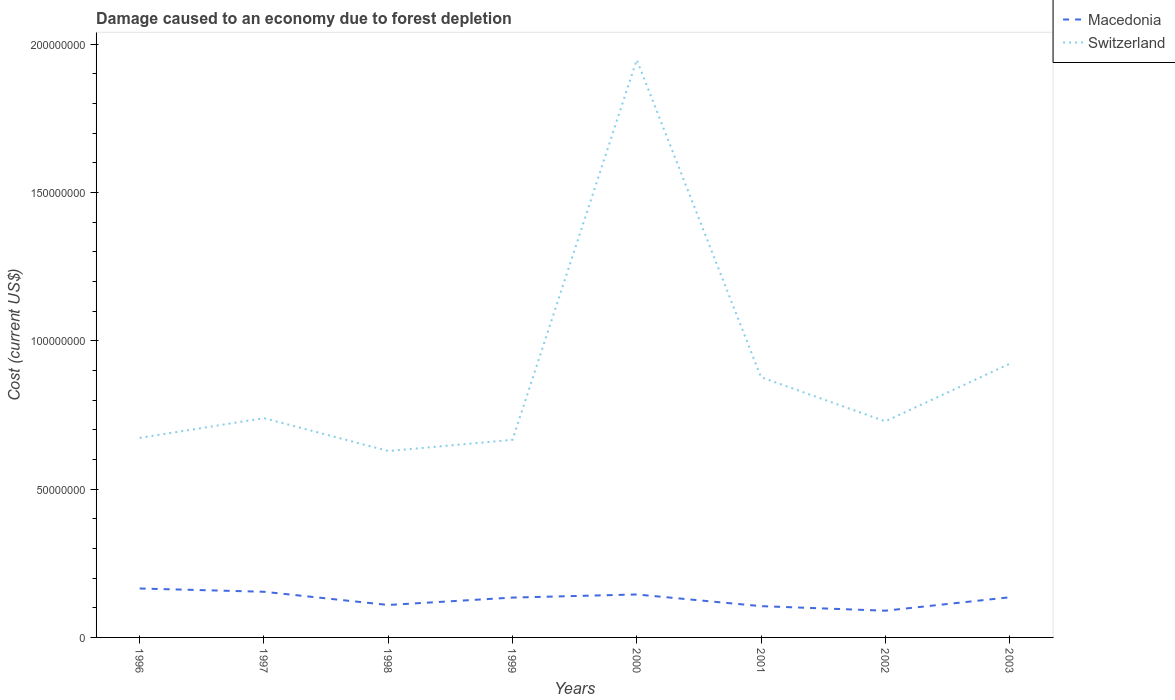How many different coloured lines are there?
Provide a short and direct response. 2. Does the line corresponding to Switzerland intersect with the line corresponding to Macedonia?
Your answer should be compact. No. Across all years, what is the maximum cost of damage caused due to forest depletion in Macedonia?
Keep it short and to the point. 9.01e+06. What is the total cost of damage caused due to forest depletion in Macedonia in the graph?
Give a very brief answer. 6.38e+06. What is the difference between the highest and the second highest cost of damage caused due to forest depletion in Switzerland?
Give a very brief answer. 1.32e+08. What is the difference between the highest and the lowest cost of damage caused due to forest depletion in Macedonia?
Offer a terse response. 5. How many lines are there?
Your answer should be very brief. 2. What is the difference between two consecutive major ticks on the Y-axis?
Offer a terse response. 5.00e+07. How are the legend labels stacked?
Your response must be concise. Vertical. What is the title of the graph?
Your answer should be very brief. Damage caused to an economy due to forest depletion. What is the label or title of the Y-axis?
Your answer should be very brief. Cost (current US$). What is the Cost (current US$) in Macedonia in 1996?
Give a very brief answer. 1.65e+07. What is the Cost (current US$) in Switzerland in 1996?
Keep it short and to the point. 6.72e+07. What is the Cost (current US$) of Macedonia in 1997?
Your response must be concise. 1.54e+07. What is the Cost (current US$) in Switzerland in 1997?
Keep it short and to the point. 7.39e+07. What is the Cost (current US$) in Macedonia in 1998?
Provide a short and direct response. 1.09e+07. What is the Cost (current US$) in Switzerland in 1998?
Your answer should be very brief. 6.28e+07. What is the Cost (current US$) of Macedonia in 1999?
Offer a terse response. 1.34e+07. What is the Cost (current US$) of Switzerland in 1999?
Your answer should be compact. 6.66e+07. What is the Cost (current US$) of Macedonia in 2000?
Ensure brevity in your answer.  1.45e+07. What is the Cost (current US$) of Switzerland in 2000?
Offer a terse response. 1.95e+08. What is the Cost (current US$) in Macedonia in 2001?
Keep it short and to the point. 1.05e+07. What is the Cost (current US$) in Switzerland in 2001?
Give a very brief answer. 8.77e+07. What is the Cost (current US$) of Macedonia in 2002?
Your answer should be compact. 9.01e+06. What is the Cost (current US$) of Switzerland in 2002?
Keep it short and to the point. 7.28e+07. What is the Cost (current US$) in Macedonia in 2003?
Offer a very short reply. 1.35e+07. What is the Cost (current US$) of Switzerland in 2003?
Keep it short and to the point. 9.22e+07. Across all years, what is the maximum Cost (current US$) in Macedonia?
Offer a terse response. 1.65e+07. Across all years, what is the maximum Cost (current US$) of Switzerland?
Your answer should be very brief. 1.95e+08. Across all years, what is the minimum Cost (current US$) in Macedonia?
Keep it short and to the point. 9.01e+06. Across all years, what is the minimum Cost (current US$) in Switzerland?
Your answer should be compact. 6.28e+07. What is the total Cost (current US$) in Macedonia in the graph?
Your answer should be compact. 1.04e+08. What is the total Cost (current US$) in Switzerland in the graph?
Provide a succinct answer. 7.18e+08. What is the difference between the Cost (current US$) in Macedonia in 1996 and that in 1997?
Keep it short and to the point. 1.11e+06. What is the difference between the Cost (current US$) of Switzerland in 1996 and that in 1997?
Offer a terse response. -6.66e+06. What is the difference between the Cost (current US$) of Macedonia in 1996 and that in 1998?
Provide a succinct answer. 5.56e+06. What is the difference between the Cost (current US$) in Switzerland in 1996 and that in 1998?
Keep it short and to the point. 4.42e+06. What is the difference between the Cost (current US$) in Macedonia in 1996 and that in 1999?
Your response must be concise. 3.06e+06. What is the difference between the Cost (current US$) of Switzerland in 1996 and that in 1999?
Offer a terse response. 6.52e+05. What is the difference between the Cost (current US$) of Macedonia in 1996 and that in 2000?
Offer a terse response. 2.01e+06. What is the difference between the Cost (current US$) of Switzerland in 1996 and that in 2000?
Give a very brief answer. -1.27e+08. What is the difference between the Cost (current US$) of Macedonia in 1996 and that in 2001?
Provide a short and direct response. 5.95e+06. What is the difference between the Cost (current US$) of Switzerland in 1996 and that in 2001?
Keep it short and to the point. -2.05e+07. What is the difference between the Cost (current US$) of Macedonia in 1996 and that in 2002?
Your answer should be compact. 7.49e+06. What is the difference between the Cost (current US$) in Switzerland in 1996 and that in 2002?
Ensure brevity in your answer.  -5.58e+06. What is the difference between the Cost (current US$) in Macedonia in 1996 and that in 2003?
Make the answer very short. 2.97e+06. What is the difference between the Cost (current US$) in Switzerland in 1996 and that in 2003?
Make the answer very short. -2.50e+07. What is the difference between the Cost (current US$) in Macedonia in 1997 and that in 1998?
Your response must be concise. 4.45e+06. What is the difference between the Cost (current US$) in Switzerland in 1997 and that in 1998?
Make the answer very short. 1.11e+07. What is the difference between the Cost (current US$) of Macedonia in 1997 and that in 1999?
Make the answer very short. 1.96e+06. What is the difference between the Cost (current US$) of Switzerland in 1997 and that in 1999?
Keep it short and to the point. 7.31e+06. What is the difference between the Cost (current US$) of Macedonia in 1997 and that in 2000?
Your answer should be very brief. 9.07e+05. What is the difference between the Cost (current US$) of Switzerland in 1997 and that in 2000?
Keep it short and to the point. -1.21e+08. What is the difference between the Cost (current US$) in Macedonia in 1997 and that in 2001?
Your answer should be compact. 4.85e+06. What is the difference between the Cost (current US$) of Switzerland in 1997 and that in 2001?
Your answer should be compact. -1.38e+07. What is the difference between the Cost (current US$) in Macedonia in 1997 and that in 2002?
Give a very brief answer. 6.38e+06. What is the difference between the Cost (current US$) of Switzerland in 1997 and that in 2002?
Your answer should be very brief. 1.08e+06. What is the difference between the Cost (current US$) in Macedonia in 1997 and that in 2003?
Keep it short and to the point. 1.86e+06. What is the difference between the Cost (current US$) of Switzerland in 1997 and that in 2003?
Make the answer very short. -1.83e+07. What is the difference between the Cost (current US$) in Macedonia in 1998 and that in 1999?
Ensure brevity in your answer.  -2.50e+06. What is the difference between the Cost (current US$) in Switzerland in 1998 and that in 1999?
Provide a succinct answer. -3.77e+06. What is the difference between the Cost (current US$) of Macedonia in 1998 and that in 2000?
Offer a very short reply. -3.55e+06. What is the difference between the Cost (current US$) in Switzerland in 1998 and that in 2000?
Give a very brief answer. -1.32e+08. What is the difference between the Cost (current US$) of Macedonia in 1998 and that in 2001?
Give a very brief answer. 3.92e+05. What is the difference between the Cost (current US$) of Switzerland in 1998 and that in 2001?
Your response must be concise. -2.49e+07. What is the difference between the Cost (current US$) in Macedonia in 1998 and that in 2002?
Your answer should be very brief. 1.93e+06. What is the difference between the Cost (current US$) in Switzerland in 1998 and that in 2002?
Your answer should be very brief. -1.00e+07. What is the difference between the Cost (current US$) of Macedonia in 1998 and that in 2003?
Give a very brief answer. -2.59e+06. What is the difference between the Cost (current US$) of Switzerland in 1998 and that in 2003?
Make the answer very short. -2.94e+07. What is the difference between the Cost (current US$) of Macedonia in 1999 and that in 2000?
Provide a succinct answer. -1.05e+06. What is the difference between the Cost (current US$) in Switzerland in 1999 and that in 2000?
Ensure brevity in your answer.  -1.28e+08. What is the difference between the Cost (current US$) in Macedonia in 1999 and that in 2001?
Offer a very short reply. 2.89e+06. What is the difference between the Cost (current US$) in Switzerland in 1999 and that in 2001?
Provide a short and direct response. -2.11e+07. What is the difference between the Cost (current US$) of Macedonia in 1999 and that in 2002?
Ensure brevity in your answer.  4.42e+06. What is the difference between the Cost (current US$) in Switzerland in 1999 and that in 2002?
Make the answer very short. -6.23e+06. What is the difference between the Cost (current US$) of Macedonia in 1999 and that in 2003?
Give a very brief answer. -9.88e+04. What is the difference between the Cost (current US$) in Switzerland in 1999 and that in 2003?
Give a very brief answer. -2.56e+07. What is the difference between the Cost (current US$) in Macedonia in 2000 and that in 2001?
Give a very brief answer. 3.94e+06. What is the difference between the Cost (current US$) of Switzerland in 2000 and that in 2001?
Make the answer very short. 1.07e+08. What is the difference between the Cost (current US$) in Macedonia in 2000 and that in 2002?
Keep it short and to the point. 5.47e+06. What is the difference between the Cost (current US$) of Switzerland in 2000 and that in 2002?
Give a very brief answer. 1.22e+08. What is the difference between the Cost (current US$) of Macedonia in 2000 and that in 2003?
Provide a succinct answer. 9.54e+05. What is the difference between the Cost (current US$) in Switzerland in 2000 and that in 2003?
Provide a short and direct response. 1.02e+08. What is the difference between the Cost (current US$) in Macedonia in 2001 and that in 2002?
Give a very brief answer. 1.53e+06. What is the difference between the Cost (current US$) in Switzerland in 2001 and that in 2002?
Offer a terse response. 1.49e+07. What is the difference between the Cost (current US$) of Macedonia in 2001 and that in 2003?
Offer a very short reply. -2.99e+06. What is the difference between the Cost (current US$) in Switzerland in 2001 and that in 2003?
Your answer should be compact. -4.52e+06. What is the difference between the Cost (current US$) of Macedonia in 2002 and that in 2003?
Offer a very short reply. -4.52e+06. What is the difference between the Cost (current US$) in Switzerland in 2002 and that in 2003?
Make the answer very short. -1.94e+07. What is the difference between the Cost (current US$) of Macedonia in 1996 and the Cost (current US$) of Switzerland in 1997?
Your response must be concise. -5.74e+07. What is the difference between the Cost (current US$) in Macedonia in 1996 and the Cost (current US$) in Switzerland in 1998?
Ensure brevity in your answer.  -4.63e+07. What is the difference between the Cost (current US$) of Macedonia in 1996 and the Cost (current US$) of Switzerland in 1999?
Provide a short and direct response. -5.01e+07. What is the difference between the Cost (current US$) in Macedonia in 1996 and the Cost (current US$) in Switzerland in 2000?
Your answer should be very brief. -1.78e+08. What is the difference between the Cost (current US$) in Macedonia in 1996 and the Cost (current US$) in Switzerland in 2001?
Give a very brief answer. -7.12e+07. What is the difference between the Cost (current US$) in Macedonia in 1996 and the Cost (current US$) in Switzerland in 2002?
Offer a very short reply. -5.63e+07. What is the difference between the Cost (current US$) in Macedonia in 1996 and the Cost (current US$) in Switzerland in 2003?
Keep it short and to the point. -7.57e+07. What is the difference between the Cost (current US$) in Macedonia in 1997 and the Cost (current US$) in Switzerland in 1998?
Give a very brief answer. -4.74e+07. What is the difference between the Cost (current US$) of Macedonia in 1997 and the Cost (current US$) of Switzerland in 1999?
Ensure brevity in your answer.  -5.12e+07. What is the difference between the Cost (current US$) of Macedonia in 1997 and the Cost (current US$) of Switzerland in 2000?
Offer a very short reply. -1.79e+08. What is the difference between the Cost (current US$) of Macedonia in 1997 and the Cost (current US$) of Switzerland in 2001?
Offer a terse response. -7.23e+07. What is the difference between the Cost (current US$) of Macedonia in 1997 and the Cost (current US$) of Switzerland in 2002?
Your answer should be very brief. -5.74e+07. What is the difference between the Cost (current US$) in Macedonia in 1997 and the Cost (current US$) in Switzerland in 2003?
Provide a short and direct response. -7.68e+07. What is the difference between the Cost (current US$) in Macedonia in 1998 and the Cost (current US$) in Switzerland in 1999?
Your answer should be compact. -5.57e+07. What is the difference between the Cost (current US$) of Macedonia in 1998 and the Cost (current US$) of Switzerland in 2000?
Make the answer very short. -1.84e+08. What is the difference between the Cost (current US$) of Macedonia in 1998 and the Cost (current US$) of Switzerland in 2001?
Provide a short and direct response. -7.68e+07. What is the difference between the Cost (current US$) in Macedonia in 1998 and the Cost (current US$) in Switzerland in 2002?
Keep it short and to the point. -6.19e+07. What is the difference between the Cost (current US$) of Macedonia in 1998 and the Cost (current US$) of Switzerland in 2003?
Make the answer very short. -8.13e+07. What is the difference between the Cost (current US$) in Macedonia in 1999 and the Cost (current US$) in Switzerland in 2000?
Keep it short and to the point. -1.81e+08. What is the difference between the Cost (current US$) of Macedonia in 1999 and the Cost (current US$) of Switzerland in 2001?
Keep it short and to the point. -7.43e+07. What is the difference between the Cost (current US$) in Macedonia in 1999 and the Cost (current US$) in Switzerland in 2002?
Your answer should be very brief. -5.94e+07. What is the difference between the Cost (current US$) in Macedonia in 1999 and the Cost (current US$) in Switzerland in 2003?
Ensure brevity in your answer.  -7.88e+07. What is the difference between the Cost (current US$) of Macedonia in 2000 and the Cost (current US$) of Switzerland in 2001?
Your response must be concise. -7.32e+07. What is the difference between the Cost (current US$) of Macedonia in 2000 and the Cost (current US$) of Switzerland in 2002?
Give a very brief answer. -5.83e+07. What is the difference between the Cost (current US$) of Macedonia in 2000 and the Cost (current US$) of Switzerland in 2003?
Make the answer very short. -7.77e+07. What is the difference between the Cost (current US$) in Macedonia in 2001 and the Cost (current US$) in Switzerland in 2002?
Keep it short and to the point. -6.23e+07. What is the difference between the Cost (current US$) in Macedonia in 2001 and the Cost (current US$) in Switzerland in 2003?
Offer a terse response. -8.17e+07. What is the difference between the Cost (current US$) of Macedonia in 2002 and the Cost (current US$) of Switzerland in 2003?
Your response must be concise. -8.32e+07. What is the average Cost (current US$) in Macedonia per year?
Keep it short and to the point. 1.30e+07. What is the average Cost (current US$) of Switzerland per year?
Provide a short and direct response. 8.98e+07. In the year 1996, what is the difference between the Cost (current US$) of Macedonia and Cost (current US$) of Switzerland?
Make the answer very short. -5.08e+07. In the year 1997, what is the difference between the Cost (current US$) of Macedonia and Cost (current US$) of Switzerland?
Your answer should be compact. -5.85e+07. In the year 1998, what is the difference between the Cost (current US$) of Macedonia and Cost (current US$) of Switzerland?
Offer a very short reply. -5.19e+07. In the year 1999, what is the difference between the Cost (current US$) of Macedonia and Cost (current US$) of Switzerland?
Provide a short and direct response. -5.32e+07. In the year 2000, what is the difference between the Cost (current US$) of Macedonia and Cost (current US$) of Switzerland?
Keep it short and to the point. -1.80e+08. In the year 2001, what is the difference between the Cost (current US$) of Macedonia and Cost (current US$) of Switzerland?
Ensure brevity in your answer.  -7.72e+07. In the year 2002, what is the difference between the Cost (current US$) in Macedonia and Cost (current US$) in Switzerland?
Your answer should be compact. -6.38e+07. In the year 2003, what is the difference between the Cost (current US$) of Macedonia and Cost (current US$) of Switzerland?
Your answer should be very brief. -7.87e+07. What is the ratio of the Cost (current US$) of Macedonia in 1996 to that in 1997?
Provide a short and direct response. 1.07. What is the ratio of the Cost (current US$) in Switzerland in 1996 to that in 1997?
Provide a succinct answer. 0.91. What is the ratio of the Cost (current US$) in Macedonia in 1996 to that in 1998?
Your answer should be very brief. 1.51. What is the ratio of the Cost (current US$) of Switzerland in 1996 to that in 1998?
Make the answer very short. 1.07. What is the ratio of the Cost (current US$) in Macedonia in 1996 to that in 1999?
Ensure brevity in your answer.  1.23. What is the ratio of the Cost (current US$) of Switzerland in 1996 to that in 1999?
Give a very brief answer. 1.01. What is the ratio of the Cost (current US$) of Macedonia in 1996 to that in 2000?
Make the answer very short. 1.14. What is the ratio of the Cost (current US$) in Switzerland in 1996 to that in 2000?
Offer a terse response. 0.35. What is the ratio of the Cost (current US$) in Macedonia in 1996 to that in 2001?
Your answer should be compact. 1.56. What is the ratio of the Cost (current US$) of Switzerland in 1996 to that in 2001?
Your answer should be very brief. 0.77. What is the ratio of the Cost (current US$) in Macedonia in 1996 to that in 2002?
Provide a succinct answer. 1.83. What is the ratio of the Cost (current US$) in Switzerland in 1996 to that in 2002?
Your answer should be very brief. 0.92. What is the ratio of the Cost (current US$) of Macedonia in 1996 to that in 2003?
Provide a short and direct response. 1.22. What is the ratio of the Cost (current US$) of Switzerland in 1996 to that in 2003?
Ensure brevity in your answer.  0.73. What is the ratio of the Cost (current US$) of Macedonia in 1997 to that in 1998?
Make the answer very short. 1.41. What is the ratio of the Cost (current US$) of Switzerland in 1997 to that in 1998?
Keep it short and to the point. 1.18. What is the ratio of the Cost (current US$) of Macedonia in 1997 to that in 1999?
Your answer should be very brief. 1.15. What is the ratio of the Cost (current US$) in Switzerland in 1997 to that in 1999?
Offer a very short reply. 1.11. What is the ratio of the Cost (current US$) in Macedonia in 1997 to that in 2000?
Offer a terse response. 1.06. What is the ratio of the Cost (current US$) in Switzerland in 1997 to that in 2000?
Provide a short and direct response. 0.38. What is the ratio of the Cost (current US$) in Macedonia in 1997 to that in 2001?
Your answer should be very brief. 1.46. What is the ratio of the Cost (current US$) in Switzerland in 1997 to that in 2001?
Give a very brief answer. 0.84. What is the ratio of the Cost (current US$) of Macedonia in 1997 to that in 2002?
Your answer should be very brief. 1.71. What is the ratio of the Cost (current US$) in Switzerland in 1997 to that in 2002?
Provide a succinct answer. 1.01. What is the ratio of the Cost (current US$) of Macedonia in 1997 to that in 2003?
Ensure brevity in your answer.  1.14. What is the ratio of the Cost (current US$) of Switzerland in 1997 to that in 2003?
Offer a very short reply. 0.8. What is the ratio of the Cost (current US$) of Macedonia in 1998 to that in 1999?
Your answer should be compact. 0.81. What is the ratio of the Cost (current US$) of Switzerland in 1998 to that in 1999?
Make the answer very short. 0.94. What is the ratio of the Cost (current US$) of Macedonia in 1998 to that in 2000?
Offer a terse response. 0.76. What is the ratio of the Cost (current US$) in Switzerland in 1998 to that in 2000?
Your answer should be very brief. 0.32. What is the ratio of the Cost (current US$) in Macedonia in 1998 to that in 2001?
Your response must be concise. 1.04. What is the ratio of the Cost (current US$) of Switzerland in 1998 to that in 2001?
Ensure brevity in your answer.  0.72. What is the ratio of the Cost (current US$) in Macedonia in 1998 to that in 2002?
Your answer should be very brief. 1.21. What is the ratio of the Cost (current US$) of Switzerland in 1998 to that in 2002?
Ensure brevity in your answer.  0.86. What is the ratio of the Cost (current US$) of Macedonia in 1998 to that in 2003?
Your answer should be compact. 0.81. What is the ratio of the Cost (current US$) in Switzerland in 1998 to that in 2003?
Your response must be concise. 0.68. What is the ratio of the Cost (current US$) in Macedonia in 1999 to that in 2000?
Provide a succinct answer. 0.93. What is the ratio of the Cost (current US$) in Switzerland in 1999 to that in 2000?
Make the answer very short. 0.34. What is the ratio of the Cost (current US$) of Macedonia in 1999 to that in 2001?
Keep it short and to the point. 1.27. What is the ratio of the Cost (current US$) in Switzerland in 1999 to that in 2001?
Offer a very short reply. 0.76. What is the ratio of the Cost (current US$) of Macedonia in 1999 to that in 2002?
Your answer should be compact. 1.49. What is the ratio of the Cost (current US$) of Switzerland in 1999 to that in 2002?
Make the answer very short. 0.91. What is the ratio of the Cost (current US$) of Macedonia in 1999 to that in 2003?
Make the answer very short. 0.99. What is the ratio of the Cost (current US$) in Switzerland in 1999 to that in 2003?
Keep it short and to the point. 0.72. What is the ratio of the Cost (current US$) in Macedonia in 2000 to that in 2001?
Your answer should be compact. 1.37. What is the ratio of the Cost (current US$) in Switzerland in 2000 to that in 2001?
Your answer should be compact. 2.22. What is the ratio of the Cost (current US$) of Macedonia in 2000 to that in 2002?
Keep it short and to the point. 1.61. What is the ratio of the Cost (current US$) in Switzerland in 2000 to that in 2002?
Make the answer very short. 2.67. What is the ratio of the Cost (current US$) in Macedonia in 2000 to that in 2003?
Offer a terse response. 1.07. What is the ratio of the Cost (current US$) in Switzerland in 2000 to that in 2003?
Offer a terse response. 2.11. What is the ratio of the Cost (current US$) of Macedonia in 2001 to that in 2002?
Offer a very short reply. 1.17. What is the ratio of the Cost (current US$) of Switzerland in 2001 to that in 2002?
Your answer should be compact. 1.2. What is the ratio of the Cost (current US$) of Macedonia in 2001 to that in 2003?
Make the answer very short. 0.78. What is the ratio of the Cost (current US$) of Switzerland in 2001 to that in 2003?
Your response must be concise. 0.95. What is the ratio of the Cost (current US$) in Macedonia in 2002 to that in 2003?
Ensure brevity in your answer.  0.67. What is the ratio of the Cost (current US$) of Switzerland in 2002 to that in 2003?
Ensure brevity in your answer.  0.79. What is the difference between the highest and the second highest Cost (current US$) in Macedonia?
Give a very brief answer. 1.11e+06. What is the difference between the highest and the second highest Cost (current US$) of Switzerland?
Make the answer very short. 1.02e+08. What is the difference between the highest and the lowest Cost (current US$) of Macedonia?
Make the answer very short. 7.49e+06. What is the difference between the highest and the lowest Cost (current US$) in Switzerland?
Offer a very short reply. 1.32e+08. 